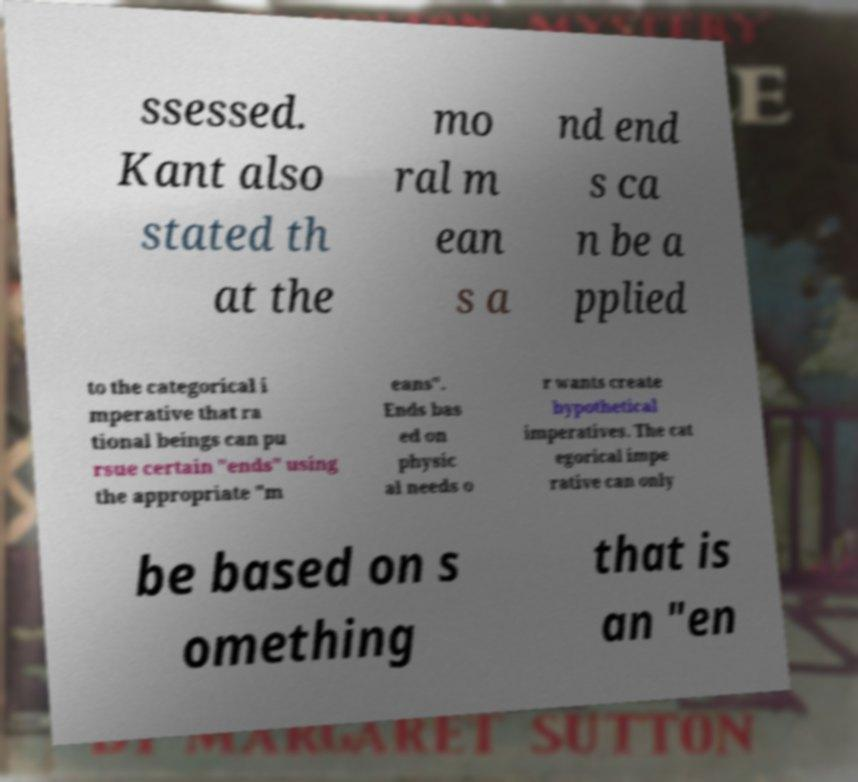Could you extract and type out the text from this image? ssessed. Kant also stated th at the mo ral m ean s a nd end s ca n be a pplied to the categorical i mperative that ra tional beings can pu rsue certain "ends" using the appropriate "m eans". Ends bas ed on physic al needs o r wants create hypothetical imperatives. The cat egorical impe rative can only be based on s omething that is an "en 